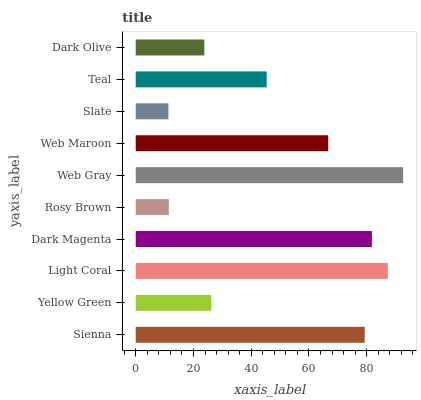Is Slate the minimum?
Answer yes or no. Yes. Is Web Gray the maximum?
Answer yes or no. Yes. Is Yellow Green the minimum?
Answer yes or no. No. Is Yellow Green the maximum?
Answer yes or no. No. Is Sienna greater than Yellow Green?
Answer yes or no. Yes. Is Yellow Green less than Sienna?
Answer yes or no. Yes. Is Yellow Green greater than Sienna?
Answer yes or no. No. Is Sienna less than Yellow Green?
Answer yes or no. No. Is Web Maroon the high median?
Answer yes or no. Yes. Is Teal the low median?
Answer yes or no. Yes. Is Slate the high median?
Answer yes or no. No. Is Yellow Green the low median?
Answer yes or no. No. 